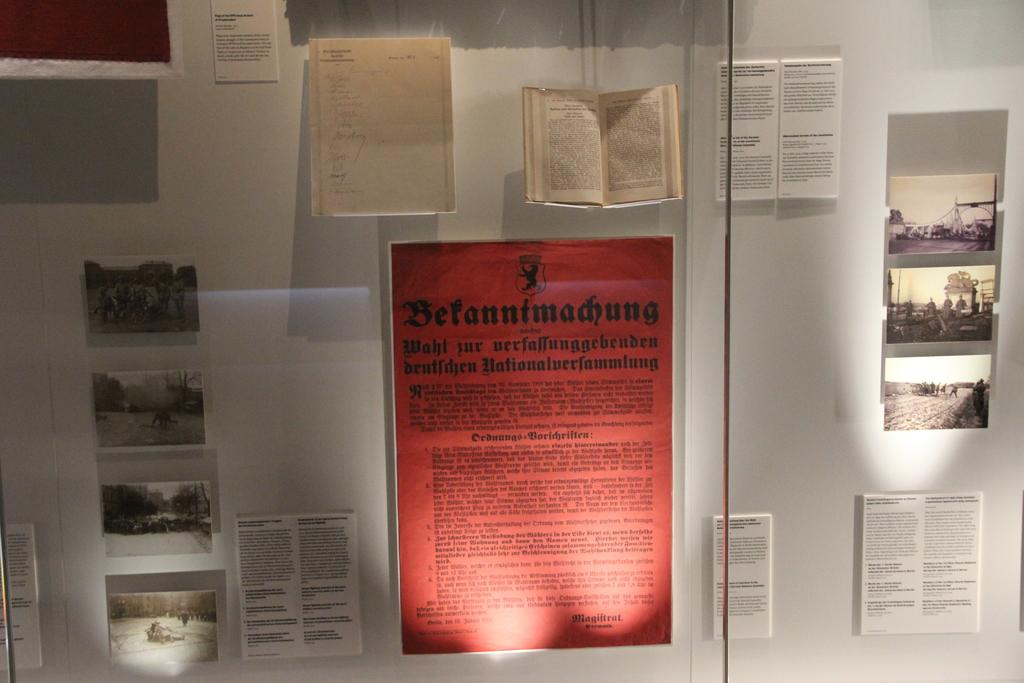<image>
Create a compact narrative representing the image presented. a group of papers on a wall one with wahl written on it. 